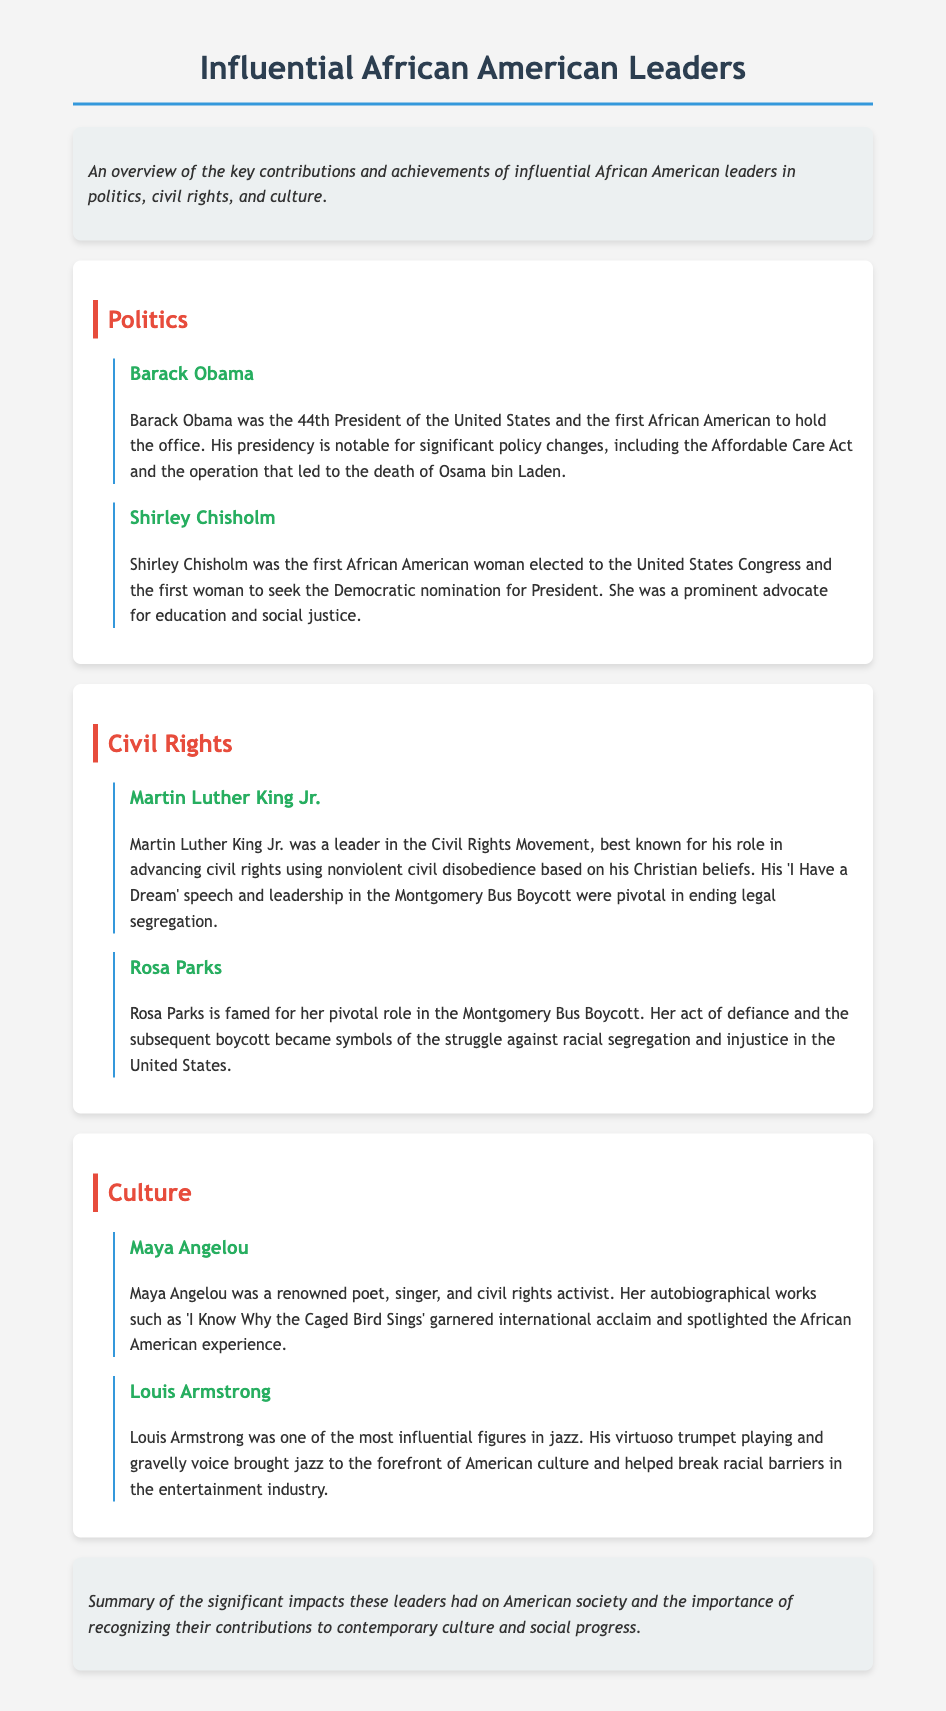What position did Barack Obama hold? Barack Obama was the 44th President of the United States, as noted in the "Politics" section.
Answer: 44th President Who was the first African American woman elected to Congress? The document states that Shirley Chisholm was the first African American woman elected to the United States Congress, as mentioned in the "Politics" section.
Answer: Shirley Chisholm What significant speech is Martin Luther King Jr. known for? The document mentions "I Have a Dream" speech as a notable aspect of Martin Luther King Jr.'s contributions in the "Civil Rights" section.
Answer: I Have a Dream What role did Rosa Parks play in the Montgomery Bus Boycott? Rosa Parks' act of defiance is highlighted in the document as pivotal to the Montgomery Bus Boycott in the "Civil Rights" section.
Answer: Pivotal role Which work is Maya Angelou internationally acclaimed for? The document mentions "I Know Why the Caged Bird Sings" as an autobiographical work that garnered international acclaim in the "Culture" section.
Answer: I Know Why the Caged Bird Sings How did Louis Armstrong impact jazz music? According to the document, Louis Armstrong's contributions helped break racial barriers and brought jazz to the forefront of American culture in the "Culture" section.
Answer: Break racial barriers What is the main focus of the document? The document provides an overview of key contributions and achievements of influential African American leaders in various fields as detailed in the introduction.
Answer: Key contributions and achievements Who was the first woman to seek the Democratic nomination for President? The document states that Shirley Chisholm was the first woman to seek the Democratic nomination for President in the "Politics" section.
Answer: Shirley Chisholm 